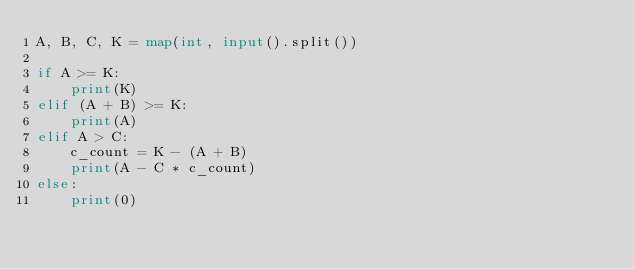Convert code to text. <code><loc_0><loc_0><loc_500><loc_500><_Python_>A, B, C, K = map(int, input().split())

if A >= K:
    print(K)
elif (A + B) >= K:
    print(A)
elif A > C:
    c_count = K - (A + B)
    print(A - C * c_count)
else:
    print(0)
</code> 